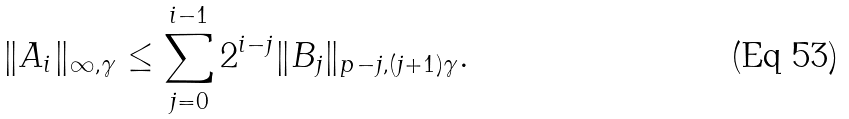<formula> <loc_0><loc_0><loc_500><loc_500>\| A _ { i } \| _ { \infty , \gamma } \leq \sum _ { j = 0 } ^ { i - 1 } 2 ^ { i - j } \| B _ { j } \| _ { p - j , ( j + 1 ) \gamma } .</formula> 